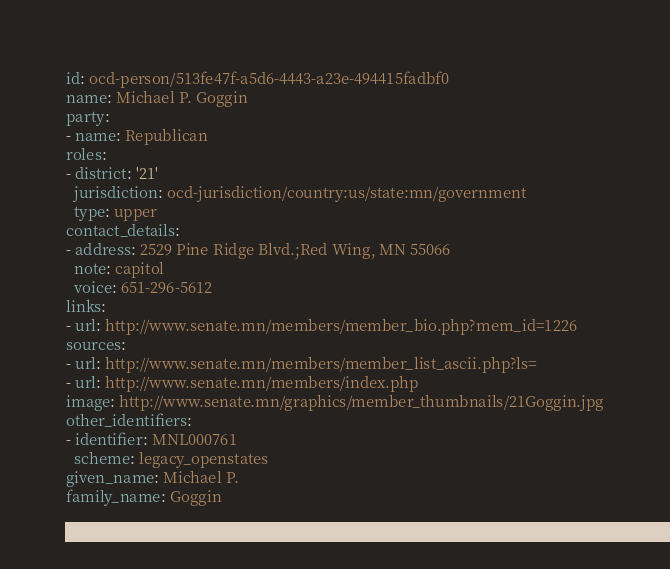Convert code to text. <code><loc_0><loc_0><loc_500><loc_500><_YAML_>id: ocd-person/513fe47f-a5d6-4443-a23e-494415fadbf0
name: Michael P. Goggin
party:
- name: Republican
roles:
- district: '21'
  jurisdiction: ocd-jurisdiction/country:us/state:mn/government
  type: upper
contact_details:
- address: 2529 Pine Ridge Blvd.;Red Wing, MN 55066
  note: capitol
  voice: 651-296-5612
links:
- url: http://www.senate.mn/members/member_bio.php?mem_id=1226
sources:
- url: http://www.senate.mn/members/member_list_ascii.php?ls=
- url: http://www.senate.mn/members/index.php
image: http://www.senate.mn/graphics/member_thumbnails/21Goggin.jpg
other_identifiers:
- identifier: MNL000761
  scheme: legacy_openstates
given_name: Michael P.
family_name: Goggin
</code> 